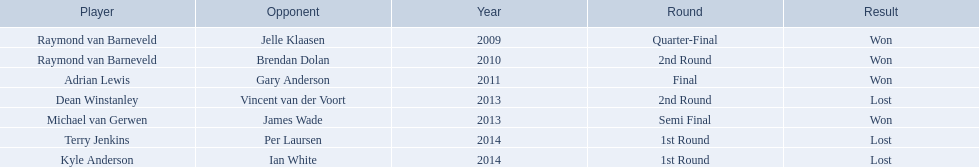Who were the players in 2014? Terry Jenkins, Kyle Anderson. Did they win or lose? Per Laursen. 